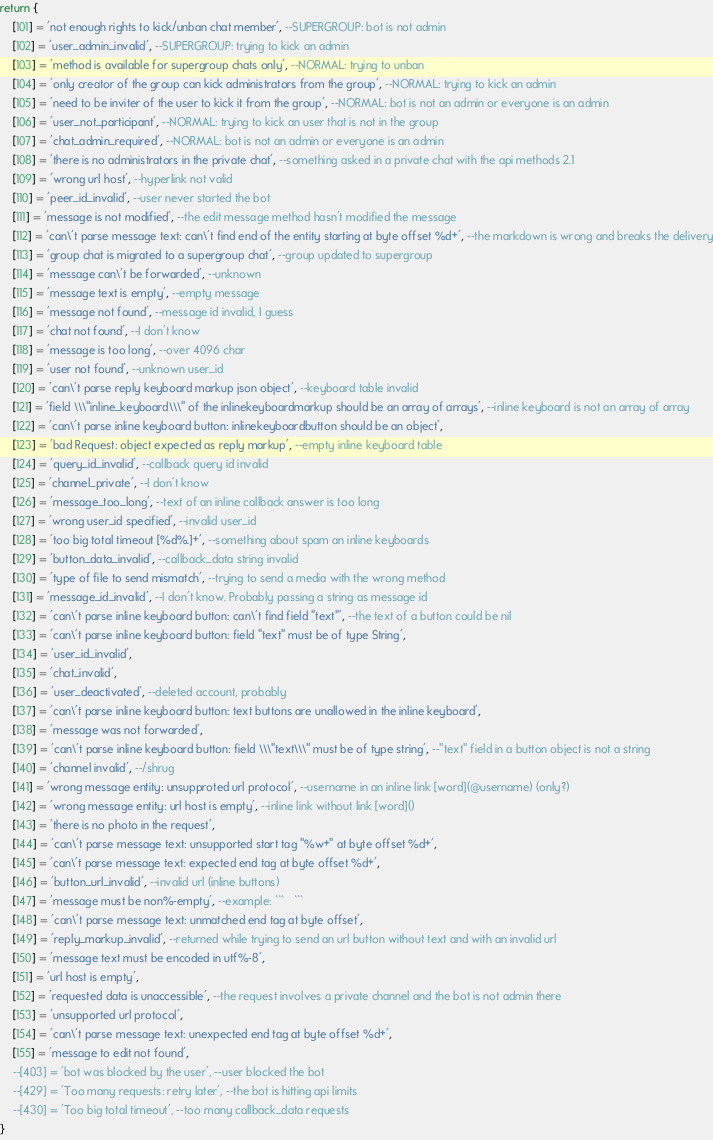<code> <loc_0><loc_0><loc_500><loc_500><_Lua_>return {
	[101] = 'not enough rights to kick/unban chat member', --SUPERGROUP: bot is not admin
	[102] = 'user_admin_invalid', --SUPERGROUP: trying to kick an admin
	[103] = 'method is available for supergroup chats only', --NORMAL: trying to unban
	[104] = 'only creator of the group can kick administrators from the group', --NORMAL: trying to kick an admin
	[105] = 'need to be inviter of the user to kick it from the group', --NORMAL: bot is not an admin or everyone is an admin
	[106] = 'user_not_participant', --NORMAL: trying to kick an user that is not in the group
	[107] = 'chat_admin_required', --NORMAL: bot is not an admin or everyone is an admin
	[108] = 'there is no administrators in the private chat', --something asked in a private chat with the api methods 2.1
	[109] = 'wrong url host', --hyperlink not valid
	[110] = 'peer_id_invalid', --user never started the bot
	[111] = 'message is not modified', --the edit message method hasn't modified the message
	[112] = 'can\'t parse message text: can\'t find end of the entity starting at byte offset %d+', --the markdown is wrong and breaks the delivery
	[113] = 'group chat is migrated to a supergroup chat', --group updated to supergroup
	[114] = 'message can\'t be forwarded', --unknown
	[115] = 'message text is empty', --empty message
	[116] = 'message not found', --message id invalid, I guess
	[117] = 'chat not found', --I don't know
	[118] = 'message is too long', --over 4096 char
	[119] = 'user not found', --unknown user_id
	[120] = 'can\'t parse reply keyboard markup json object', --keyboard table invalid
	[121] = 'field \\\"inline_keyboard\\\" of the inlinekeyboardmarkup should be an array of arrays', --inline keyboard is not an array of array
	[122] = 'can\'t parse inline keyboard button: inlinekeyboardbutton should be an object',
	[123] = 'bad Request: object expected as reply markup', --empty inline keyboard table
	[124] = 'query_id_invalid', --callback query id invalid
	[125] = 'channel_private', --I don't know
	[126] = 'message_too_long', --text of an inline callback answer is too long
	[127] = 'wrong user_id specified', --invalid user_id
	[128] = 'too big total timeout [%d%.]+', --something about spam an inline keyboards
	[129] = 'button_data_invalid', --callback_data string invalid
	[130] = 'type of file to send mismatch', --trying to send a media with the wrong method
	[131] = 'message_id_invalid', --I don't know. Probably passing a string as message id
	[132] = 'can\'t parse inline keyboard button: can\'t find field "text"', --the text of a button could be nil
	[133] = 'can\'t parse inline keyboard button: field "text" must be of type String',
	[134] = 'user_id_invalid',
	[135] = 'chat_invalid',
	[136] = 'user_deactivated', --deleted account, probably
	[137] = 'can\'t parse inline keyboard button: text buttons are unallowed in the inline keyboard',
	[138] = 'message was not forwarded',
	[139] = 'can\'t parse inline keyboard button: field \\\"text\\\" must be of type string', --"text" field in a button object is not a string
	[140] = 'channel invalid', --/shrug
	[141] = 'wrong message entity: unsupproted url protocol', --username in an inline link [word](@username) (only?)
	[142] = 'wrong message entity: url host is empty', --inline link without link [word]()
	[143] = 'there is no photo in the request',
	[144] = 'can\'t parse message text: unsupported start tag "%w+" at byte offset %d+',
	[145] = 'can\'t parse message text: expected end tag at byte offset %d+',
	[146] = 'button_url_invalid', --invalid url (inline buttons)
	[147] = 'message must be non%-empty', --example: ```   ```
	[148] = 'can\'t parse message text: unmatched end tag at byte offset',
	[149] = 'reply_markup_invalid', --returned while trying to send an url button without text and with an invalid url
	[150] = 'message text must be encoded in utf%-8',
	[151] = 'url host is empty',
	[152] = 'requested data is unaccessible', --the request involves a private channel and the bot is not admin there
	[153] = 'unsupported url protocol',
	[154] = 'can\'t parse message text: unexpected end tag at byte offset %d+',
	[155] = 'message to edit not found',
	--[403] = 'bot was blocked by the user', --user blocked the bot
	--[429] = 'Too many requests: retry later', --the bot is hitting api limits
	--[430] = 'Too big total timeout', --too many callback_data requests
}</code> 